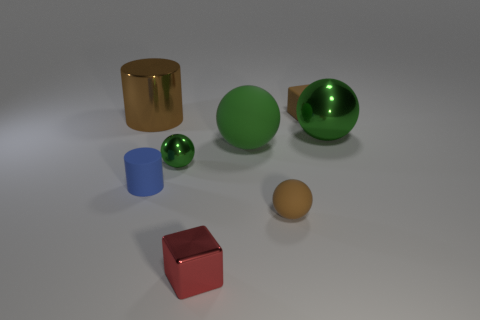Does the large metal sphere have the same color as the tiny metallic sphere?
Your answer should be very brief. Yes. Is there a tiny rubber sphere of the same color as the shiny cylinder?
Ensure brevity in your answer.  Yes. Do the block that is behind the red metal cube and the green ball on the left side of the red block have the same material?
Ensure brevity in your answer.  No. The big cylinder is what color?
Ensure brevity in your answer.  Brown. How big is the blue cylinder left of the large metal thing on the right side of the small ball that is to the left of the tiny red block?
Offer a very short reply. Small. What number of other objects are the same size as the brown rubber block?
Provide a succinct answer. 4. How many purple spheres have the same material as the big brown object?
Offer a very short reply. 0. What shape is the large green object that is right of the tiny brown cube?
Provide a short and direct response. Sphere. Are the tiny red object and the brown thing left of the tiny green sphere made of the same material?
Your answer should be very brief. Yes. Are any brown metal cylinders visible?
Your answer should be compact. Yes. 